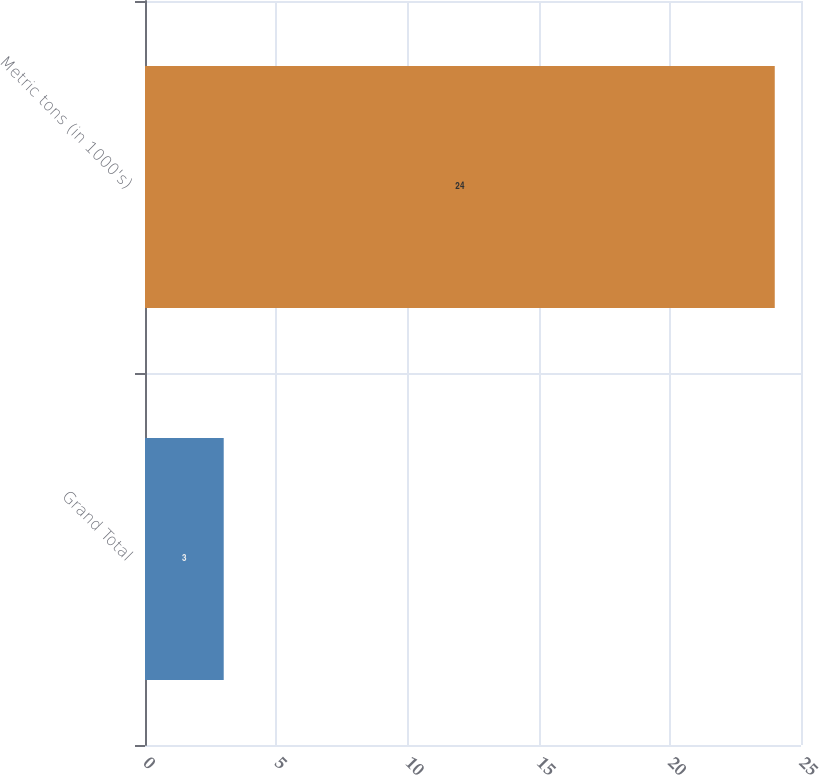Convert chart to OTSL. <chart><loc_0><loc_0><loc_500><loc_500><bar_chart><fcel>Grand Total<fcel>Metric tons (in 1000's)<nl><fcel>3<fcel>24<nl></chart> 